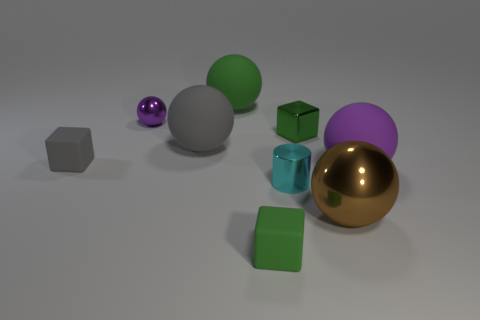Subtract all big purple rubber balls. How many balls are left? 4 Add 1 small green matte things. How many objects exist? 10 Subtract all brown balls. Subtract all purple cylinders. How many balls are left? 4 Subtract all blocks. How many objects are left? 6 Add 8 small gray blocks. How many small gray blocks are left? 9 Add 5 large gray spheres. How many large gray spheres exist? 6 Subtract 0 gray cylinders. How many objects are left? 9 Subtract all large green rubber objects. Subtract all small metallic things. How many objects are left? 5 